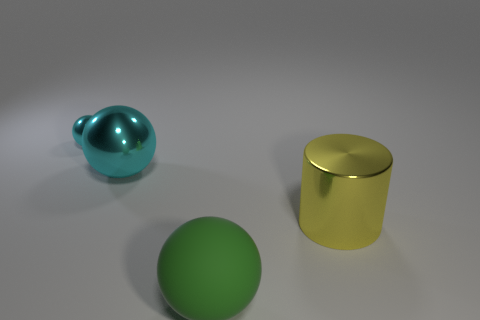Is there any other thing that has the same color as the rubber sphere?
Provide a succinct answer. No. Are there any other things that are the same material as the large green ball?
Provide a short and direct response. No. What is the color of the metal cylinder?
Your answer should be very brief. Yellow. What is the shape of the other metal thing that is the same color as the tiny object?
Offer a very short reply. Sphere. What color is the shiny object that is the same size as the yellow shiny cylinder?
Your answer should be compact. Cyan. How many rubber objects are yellow objects or large things?
Give a very brief answer. 1. What number of balls are on the left side of the green rubber object and in front of the tiny cyan shiny thing?
Your answer should be very brief. 1. Is there anything else that has the same shape as the green thing?
Provide a succinct answer. Yes. What number of other objects are there of the same size as the cylinder?
Keep it short and to the point. 2. Does the object that is to the right of the matte ball have the same size as the thing that is behind the big cyan shiny sphere?
Your response must be concise. No. 